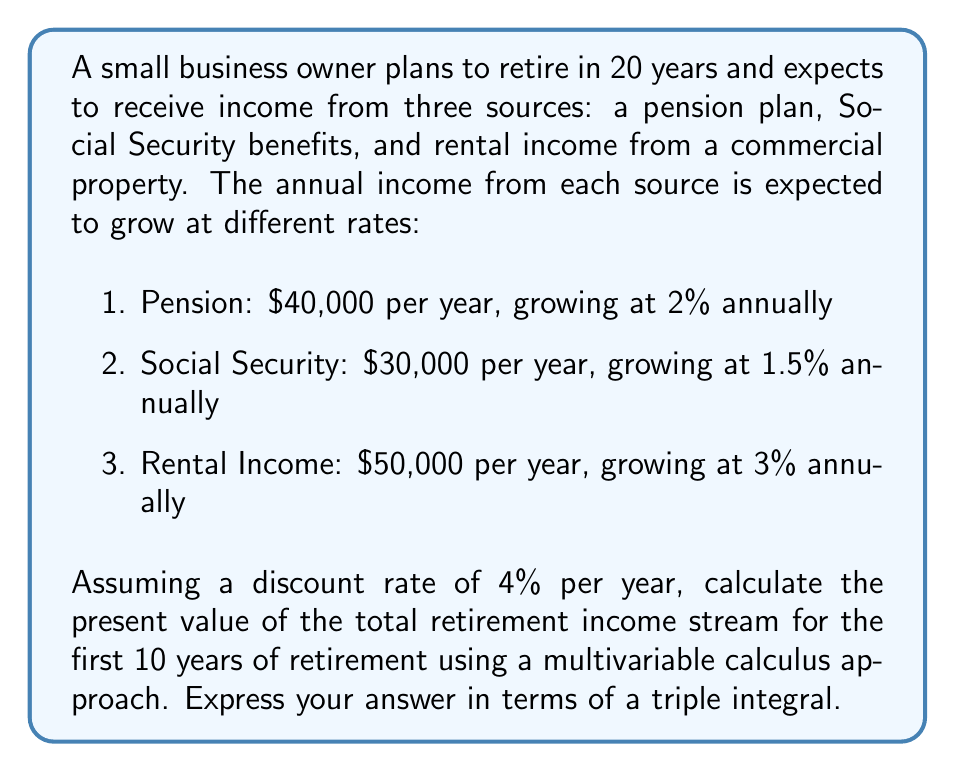Help me with this question. To solve this problem, we need to use multivariable calculus to set up a triple integral that represents the present value of the three income streams over the 10-year period.

Let's define our variables:
$t$ = time in years since retirement (0 ≤ t ≤ 10)
$x$ = pension income
$y$ = Social Security income
$z$ = rental income

Step 1: Express each income stream as a function of time:
$$x(t) = 40000 \cdot (1.02)^{t+20}$$
$$y(t) = 30000 \cdot (1.015)^{t+20}$$
$$z(t) = 50000 \cdot (1.03)^{t+20}$$

Step 2: Set up the present value function for each income stream:
$$PV(t) = \frac{x(t) + y(t) + z(t)}{(1.04)^{t+20}}$$

Step 3: Express the total present value as a triple integral:

$$\iiint_{V} \frac{x + y + z}{(1.04)^{t+20}} dx dy dz dt$$

Where V is the volume defined by:
0 ≤ t ≤ 10
$40000 \cdot (1.02)^{t+20} \leq x \leq 40000 \cdot (1.02)^{t+21}$
$30000 \cdot (1.015)^{t+20} \leq y \leq 30000 \cdot (1.015)^{t+21}$
$50000 \cdot (1.03)^{t+20} \leq z \leq 50000 \cdot (1.03)^{t+21}$

This integral represents the present value of all possible combinations of the three income streams over the 10-year period, taking into account their respective growth rates and the discount rate.
Answer: The present value of the total retirement income stream for the first 10 years of retirement can be expressed as:

$$\int_{0}^{10} \int_{40000 \cdot (1.02)^{t+20}}^{40000 \cdot (1.02)^{t+21}} \int_{30000 \cdot (1.015)^{t+20}}^{30000 \cdot (1.015)^{t+21}} \int_{50000 \cdot (1.03)^{t+20}}^{50000 \cdot (1.03)^{t+21}} \frac{x + y + z}{(1.04)^{t+20}} dz dy dx dt$$ 